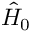<formula> <loc_0><loc_0><loc_500><loc_500>{ \hat { H } } _ { 0 }</formula> 